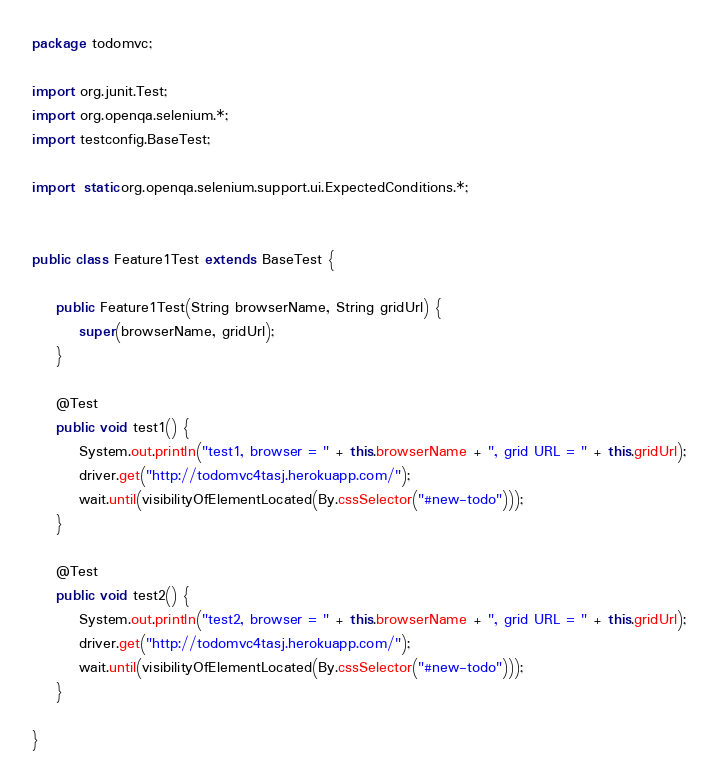<code> <loc_0><loc_0><loc_500><loc_500><_Java_>package todomvc;

import org.junit.Test;
import org.openqa.selenium.*;
import testconfig.BaseTest;

import static org.openqa.selenium.support.ui.ExpectedConditions.*;


public class Feature1Test extends BaseTest {

    public Feature1Test(String browserName, String gridUrl) {
        super(browserName, gridUrl);
    }

    @Test
    public void test1() {
        System.out.println("test1, browser = " + this.browserName + ", grid URL = " + this.gridUrl);
        driver.get("http://todomvc4tasj.herokuapp.com/");
        wait.until(visibilityOfElementLocated(By.cssSelector("#new-todo")));
    }

    @Test
    public void test2() {
        System.out.println("test2, browser = " + this.browserName + ", grid URL = " + this.gridUrl);
        driver.get("http://todomvc4tasj.herokuapp.com/");
        wait.until(visibilityOfElementLocated(By.cssSelector("#new-todo")));
    }

}
</code> 